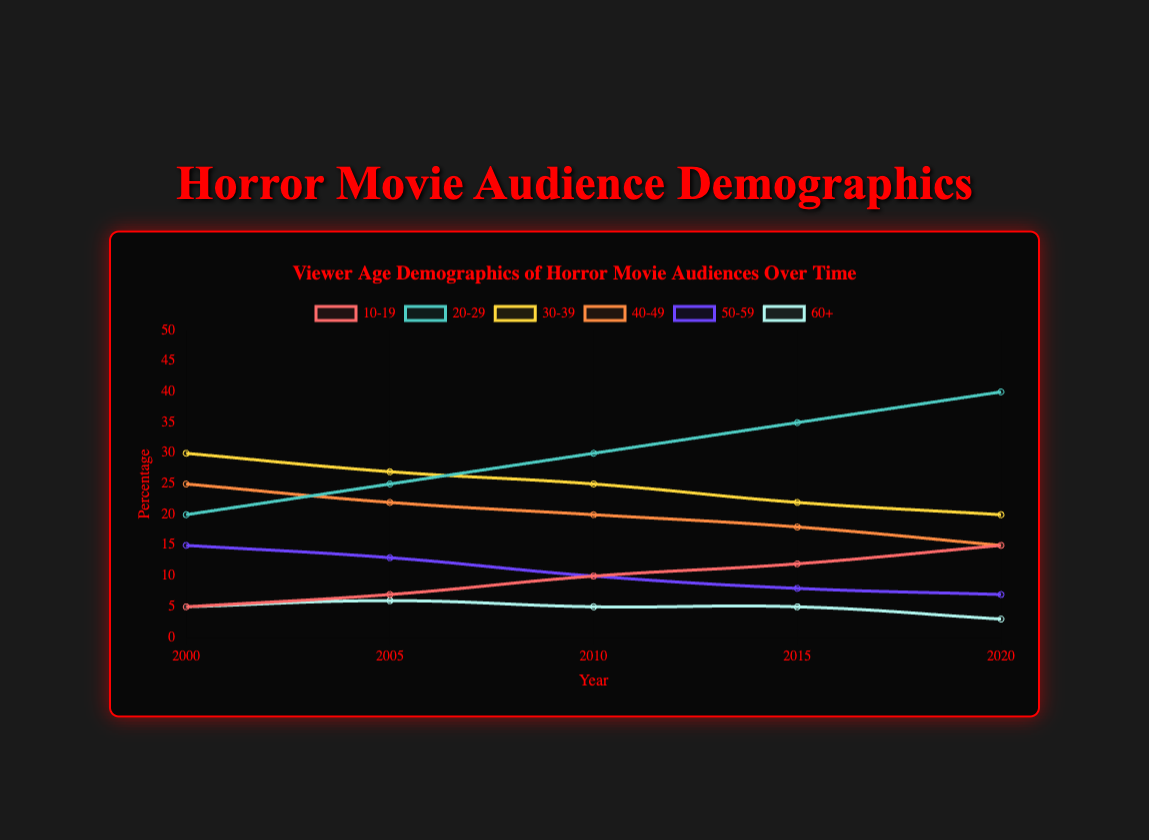What's the trend in viewership for the 20-29 age group from 2000 to 2020? The viewership for the 20-29 age group consistently increased over the specified years: from 20% in 2000, to 25% in 2005, to 30% in 2010, to 35% in 2015, and finally to 40% in 2020.
Answer: Increasing In the year 2000, which age group had the highest percentage of viewers? The highest percentage of viewers in 2000 was in the 30-39 age group with 30%.
Answer: 30-39 age group How did the viewership percentage for the 10-19 age group change between 2000 and 2020? The viewership percentage for the 10-19 age group increased from 5% in 2000 to 15% in 2020.
Answer: Increased by 10% Which age group saw the most significant decrease in viewership from 2000 to 2020? The 30-39 age group saw a decrease from 30% in 2000 to 20% in 2020, a 10% drop.
Answer: 30-39 age group Compare the trends of the 40-49 and 50-59 age groups from 2000 to 2020. The 40-49 age group's viewership dropped from 25% in 2000 to 15% in 2020. The 50-59 age group's viewership decreased from 15% in 2000 to 7% in 2020. Both groups saw a decline, but the 40-49 group had a larger absolute decrease.
Answer: 40-49 group had a larger decrease In which year did the percentage of viewers in the 10-19 age group increase the most? The largest increase for the 10-19 age group occurred between 2010 (10%) and 2015 (12%), an increase of 2%.
Answer: Between 2010 and 2015 What are the viewership percentage differences between the 20-29 and 30-39 age groups in 2020? In 2020, the 20-29 age group had a viewership of 40%, and the 30-39 age group had 20%. The difference is 40 - 20 = 20%.
Answer: 20% How did the viewership for the 60+ age group change from 2010 to 2020? The viewership for the 60+ age group decreased from 5% in 2010 to 3% in 2020.
Answer: Decreased by 2% Which year had the highest total percentage of viewership across all age groups combined? Summing up the percentages for each year: 2000 is 100%, 2005 is 100%, 2010 is 100%, 2015 is 100%, and 2020 is 100%. Each year had a total of 100%.
Answer: All years have 100% What color represents the 50-59 age group in the plot? The 50-59 age group is represented by the color purple in the plot.
Answer: Purple 